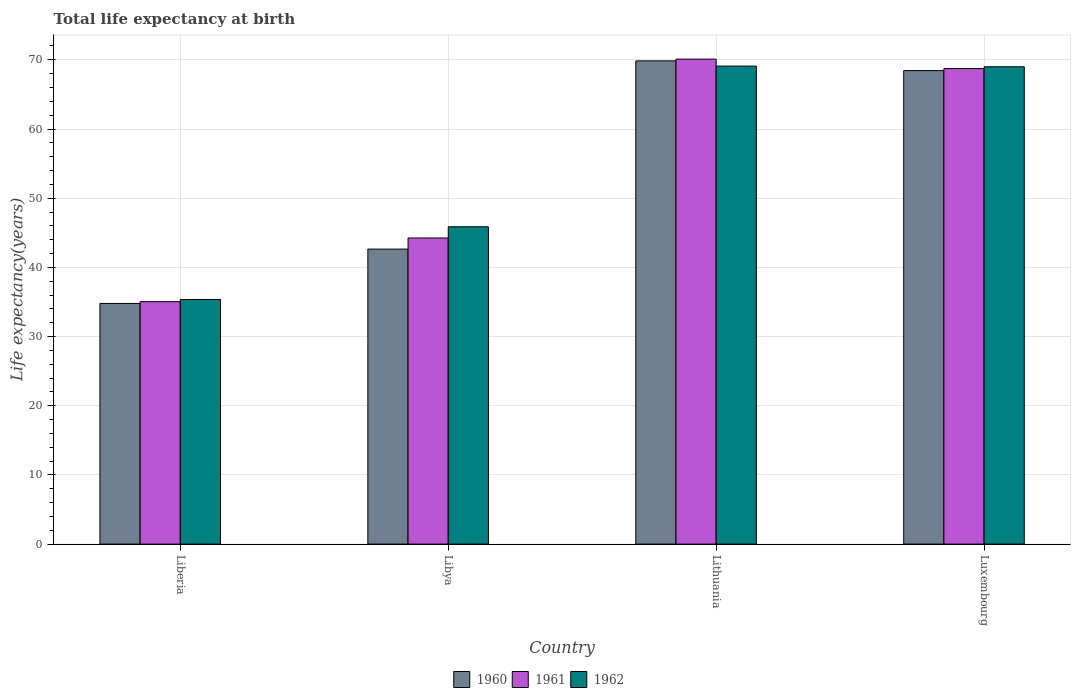Are the number of bars on each tick of the X-axis equal?
Give a very brief answer. Yes. How many bars are there on the 3rd tick from the right?
Keep it short and to the point. 3. What is the label of the 1st group of bars from the left?
Offer a terse response. Liberia. What is the life expectancy at birth in in 1961 in Libya?
Your response must be concise. 44.25. Across all countries, what is the maximum life expectancy at birth in in 1962?
Provide a succinct answer. 69.1. Across all countries, what is the minimum life expectancy at birth in in 1962?
Give a very brief answer. 35.35. In which country was the life expectancy at birth in in 1960 maximum?
Provide a succinct answer. Lithuania. In which country was the life expectancy at birth in in 1960 minimum?
Ensure brevity in your answer.  Liberia. What is the total life expectancy at birth in in 1961 in the graph?
Keep it short and to the point. 218.13. What is the difference between the life expectancy at birth in in 1960 in Libya and that in Luxembourg?
Your response must be concise. -25.81. What is the difference between the life expectancy at birth in in 1960 in Libya and the life expectancy at birth in in 1961 in Luxembourg?
Offer a terse response. -26.1. What is the average life expectancy at birth in in 1961 per country?
Offer a very short reply. 54.53. What is the difference between the life expectancy at birth in of/in 1960 and life expectancy at birth in of/in 1961 in Lithuania?
Keep it short and to the point. -0.26. In how many countries, is the life expectancy at birth in in 1961 greater than 6 years?
Ensure brevity in your answer.  4. What is the ratio of the life expectancy at birth in in 1960 in Liberia to that in Libya?
Offer a terse response. 0.82. Is the life expectancy at birth in in 1960 in Liberia less than that in Lithuania?
Offer a very short reply. Yes. What is the difference between the highest and the second highest life expectancy at birth in in 1962?
Make the answer very short. -23.13. What is the difference between the highest and the lowest life expectancy at birth in in 1961?
Offer a terse response. 35.06. How many bars are there?
Offer a very short reply. 12. Are all the bars in the graph horizontal?
Give a very brief answer. No. How many countries are there in the graph?
Give a very brief answer. 4. What is the difference between two consecutive major ticks on the Y-axis?
Give a very brief answer. 10. Are the values on the major ticks of Y-axis written in scientific E-notation?
Provide a succinct answer. No. Does the graph contain grids?
Your answer should be very brief. Yes. How many legend labels are there?
Provide a succinct answer. 3. What is the title of the graph?
Keep it short and to the point. Total life expectancy at birth. What is the label or title of the X-axis?
Your answer should be very brief. Country. What is the label or title of the Y-axis?
Ensure brevity in your answer.  Life expectancy(years). What is the Life expectancy(years) of 1960 in Liberia?
Your answer should be compact. 34.78. What is the Life expectancy(years) in 1961 in Liberia?
Offer a terse response. 35.05. What is the Life expectancy(years) in 1962 in Liberia?
Offer a terse response. 35.35. What is the Life expectancy(years) in 1960 in Libya?
Offer a terse response. 42.64. What is the Life expectancy(years) in 1961 in Libya?
Provide a short and direct response. 44.25. What is the Life expectancy(years) of 1962 in Libya?
Provide a succinct answer. 45.87. What is the Life expectancy(years) of 1960 in Lithuania?
Offer a very short reply. 69.85. What is the Life expectancy(years) of 1961 in Lithuania?
Your answer should be very brief. 70.1. What is the Life expectancy(years) of 1962 in Lithuania?
Keep it short and to the point. 69.1. What is the Life expectancy(years) in 1960 in Luxembourg?
Your response must be concise. 68.45. What is the Life expectancy(years) of 1961 in Luxembourg?
Ensure brevity in your answer.  68.74. What is the Life expectancy(years) of 1962 in Luxembourg?
Offer a terse response. 69. Across all countries, what is the maximum Life expectancy(years) in 1960?
Provide a succinct answer. 69.85. Across all countries, what is the maximum Life expectancy(years) in 1961?
Your response must be concise. 70.1. Across all countries, what is the maximum Life expectancy(years) of 1962?
Keep it short and to the point. 69.1. Across all countries, what is the minimum Life expectancy(years) of 1960?
Make the answer very short. 34.78. Across all countries, what is the minimum Life expectancy(years) in 1961?
Ensure brevity in your answer.  35.05. Across all countries, what is the minimum Life expectancy(years) of 1962?
Provide a short and direct response. 35.35. What is the total Life expectancy(years) of 1960 in the graph?
Your answer should be compact. 215.72. What is the total Life expectancy(years) in 1961 in the graph?
Keep it short and to the point. 218.13. What is the total Life expectancy(years) in 1962 in the graph?
Your response must be concise. 219.32. What is the difference between the Life expectancy(years) in 1960 in Liberia and that in Libya?
Give a very brief answer. -7.86. What is the difference between the Life expectancy(years) of 1961 in Liberia and that in Libya?
Your answer should be very brief. -9.2. What is the difference between the Life expectancy(years) in 1962 in Liberia and that in Libya?
Provide a short and direct response. -10.52. What is the difference between the Life expectancy(years) in 1960 in Liberia and that in Lithuania?
Keep it short and to the point. -35.06. What is the difference between the Life expectancy(years) in 1961 in Liberia and that in Lithuania?
Ensure brevity in your answer.  -35.06. What is the difference between the Life expectancy(years) of 1962 in Liberia and that in Lithuania?
Keep it short and to the point. -33.74. What is the difference between the Life expectancy(years) of 1960 in Liberia and that in Luxembourg?
Your answer should be compact. -33.66. What is the difference between the Life expectancy(years) of 1961 in Liberia and that in Luxembourg?
Your response must be concise. -33.69. What is the difference between the Life expectancy(years) of 1962 in Liberia and that in Luxembourg?
Your answer should be very brief. -33.64. What is the difference between the Life expectancy(years) of 1960 in Libya and that in Lithuania?
Give a very brief answer. -27.21. What is the difference between the Life expectancy(years) in 1961 in Libya and that in Lithuania?
Provide a short and direct response. -25.86. What is the difference between the Life expectancy(years) of 1962 in Libya and that in Lithuania?
Your response must be concise. -23.22. What is the difference between the Life expectancy(years) of 1960 in Libya and that in Luxembourg?
Offer a very short reply. -25.81. What is the difference between the Life expectancy(years) in 1961 in Libya and that in Luxembourg?
Offer a very short reply. -24.49. What is the difference between the Life expectancy(years) of 1962 in Libya and that in Luxembourg?
Keep it short and to the point. -23.13. What is the difference between the Life expectancy(years) in 1960 in Lithuania and that in Luxembourg?
Offer a very short reply. 1.4. What is the difference between the Life expectancy(years) in 1961 in Lithuania and that in Luxembourg?
Give a very brief answer. 1.36. What is the difference between the Life expectancy(years) in 1962 in Lithuania and that in Luxembourg?
Make the answer very short. 0.1. What is the difference between the Life expectancy(years) in 1960 in Liberia and the Life expectancy(years) in 1961 in Libya?
Offer a very short reply. -9.46. What is the difference between the Life expectancy(years) in 1960 in Liberia and the Life expectancy(years) in 1962 in Libya?
Offer a very short reply. -11.09. What is the difference between the Life expectancy(years) in 1961 in Liberia and the Life expectancy(years) in 1962 in Libya?
Give a very brief answer. -10.82. What is the difference between the Life expectancy(years) of 1960 in Liberia and the Life expectancy(years) of 1961 in Lithuania?
Make the answer very short. -35.32. What is the difference between the Life expectancy(years) of 1960 in Liberia and the Life expectancy(years) of 1962 in Lithuania?
Provide a short and direct response. -34.31. What is the difference between the Life expectancy(years) of 1961 in Liberia and the Life expectancy(years) of 1962 in Lithuania?
Ensure brevity in your answer.  -34.05. What is the difference between the Life expectancy(years) of 1960 in Liberia and the Life expectancy(years) of 1961 in Luxembourg?
Your response must be concise. -33.95. What is the difference between the Life expectancy(years) of 1960 in Liberia and the Life expectancy(years) of 1962 in Luxembourg?
Ensure brevity in your answer.  -34.22. What is the difference between the Life expectancy(years) in 1961 in Liberia and the Life expectancy(years) in 1962 in Luxembourg?
Provide a short and direct response. -33.95. What is the difference between the Life expectancy(years) in 1960 in Libya and the Life expectancy(years) in 1961 in Lithuania?
Provide a succinct answer. -27.46. What is the difference between the Life expectancy(years) of 1960 in Libya and the Life expectancy(years) of 1962 in Lithuania?
Keep it short and to the point. -26.45. What is the difference between the Life expectancy(years) in 1961 in Libya and the Life expectancy(years) in 1962 in Lithuania?
Keep it short and to the point. -24.85. What is the difference between the Life expectancy(years) in 1960 in Libya and the Life expectancy(years) in 1961 in Luxembourg?
Make the answer very short. -26.1. What is the difference between the Life expectancy(years) in 1960 in Libya and the Life expectancy(years) in 1962 in Luxembourg?
Offer a terse response. -26.36. What is the difference between the Life expectancy(years) of 1961 in Libya and the Life expectancy(years) of 1962 in Luxembourg?
Your answer should be very brief. -24.75. What is the difference between the Life expectancy(years) of 1960 in Lithuania and the Life expectancy(years) of 1961 in Luxembourg?
Make the answer very short. 1.11. What is the difference between the Life expectancy(years) of 1960 in Lithuania and the Life expectancy(years) of 1962 in Luxembourg?
Offer a terse response. 0.85. What is the difference between the Life expectancy(years) in 1961 in Lithuania and the Life expectancy(years) in 1962 in Luxembourg?
Provide a short and direct response. 1.1. What is the average Life expectancy(years) in 1960 per country?
Ensure brevity in your answer.  53.93. What is the average Life expectancy(years) of 1961 per country?
Ensure brevity in your answer.  54.53. What is the average Life expectancy(years) of 1962 per country?
Offer a very short reply. 54.83. What is the difference between the Life expectancy(years) in 1960 and Life expectancy(years) in 1961 in Liberia?
Your answer should be very brief. -0.26. What is the difference between the Life expectancy(years) of 1960 and Life expectancy(years) of 1962 in Liberia?
Provide a short and direct response. -0.57. What is the difference between the Life expectancy(years) of 1961 and Life expectancy(years) of 1962 in Liberia?
Offer a terse response. -0.31. What is the difference between the Life expectancy(years) in 1960 and Life expectancy(years) in 1961 in Libya?
Make the answer very short. -1.61. What is the difference between the Life expectancy(years) in 1960 and Life expectancy(years) in 1962 in Libya?
Make the answer very short. -3.23. What is the difference between the Life expectancy(years) of 1961 and Life expectancy(years) of 1962 in Libya?
Provide a succinct answer. -1.62. What is the difference between the Life expectancy(years) of 1960 and Life expectancy(years) of 1961 in Lithuania?
Give a very brief answer. -0.26. What is the difference between the Life expectancy(years) of 1960 and Life expectancy(years) of 1962 in Lithuania?
Your answer should be very brief. 0.75. What is the difference between the Life expectancy(years) in 1961 and Life expectancy(years) in 1962 in Lithuania?
Provide a short and direct response. 1.01. What is the difference between the Life expectancy(years) of 1960 and Life expectancy(years) of 1961 in Luxembourg?
Your answer should be very brief. -0.29. What is the difference between the Life expectancy(years) of 1960 and Life expectancy(years) of 1962 in Luxembourg?
Keep it short and to the point. -0.55. What is the difference between the Life expectancy(years) in 1961 and Life expectancy(years) in 1962 in Luxembourg?
Give a very brief answer. -0.26. What is the ratio of the Life expectancy(years) of 1960 in Liberia to that in Libya?
Offer a very short reply. 0.82. What is the ratio of the Life expectancy(years) in 1961 in Liberia to that in Libya?
Your answer should be compact. 0.79. What is the ratio of the Life expectancy(years) in 1962 in Liberia to that in Libya?
Offer a terse response. 0.77. What is the ratio of the Life expectancy(years) in 1960 in Liberia to that in Lithuania?
Your answer should be very brief. 0.5. What is the ratio of the Life expectancy(years) in 1961 in Liberia to that in Lithuania?
Ensure brevity in your answer.  0.5. What is the ratio of the Life expectancy(years) in 1962 in Liberia to that in Lithuania?
Offer a terse response. 0.51. What is the ratio of the Life expectancy(years) of 1960 in Liberia to that in Luxembourg?
Offer a terse response. 0.51. What is the ratio of the Life expectancy(years) in 1961 in Liberia to that in Luxembourg?
Make the answer very short. 0.51. What is the ratio of the Life expectancy(years) of 1962 in Liberia to that in Luxembourg?
Your response must be concise. 0.51. What is the ratio of the Life expectancy(years) in 1960 in Libya to that in Lithuania?
Give a very brief answer. 0.61. What is the ratio of the Life expectancy(years) of 1961 in Libya to that in Lithuania?
Provide a short and direct response. 0.63. What is the ratio of the Life expectancy(years) in 1962 in Libya to that in Lithuania?
Offer a terse response. 0.66. What is the ratio of the Life expectancy(years) of 1960 in Libya to that in Luxembourg?
Keep it short and to the point. 0.62. What is the ratio of the Life expectancy(years) of 1961 in Libya to that in Luxembourg?
Provide a succinct answer. 0.64. What is the ratio of the Life expectancy(years) in 1962 in Libya to that in Luxembourg?
Provide a succinct answer. 0.66. What is the ratio of the Life expectancy(years) of 1960 in Lithuania to that in Luxembourg?
Your answer should be very brief. 1.02. What is the ratio of the Life expectancy(years) in 1961 in Lithuania to that in Luxembourg?
Ensure brevity in your answer.  1.02. What is the ratio of the Life expectancy(years) of 1962 in Lithuania to that in Luxembourg?
Your response must be concise. 1. What is the difference between the highest and the second highest Life expectancy(years) in 1960?
Provide a succinct answer. 1.4. What is the difference between the highest and the second highest Life expectancy(years) in 1961?
Make the answer very short. 1.36. What is the difference between the highest and the second highest Life expectancy(years) in 1962?
Provide a succinct answer. 0.1. What is the difference between the highest and the lowest Life expectancy(years) of 1960?
Your answer should be very brief. 35.06. What is the difference between the highest and the lowest Life expectancy(years) in 1961?
Provide a short and direct response. 35.06. What is the difference between the highest and the lowest Life expectancy(years) in 1962?
Your answer should be very brief. 33.74. 